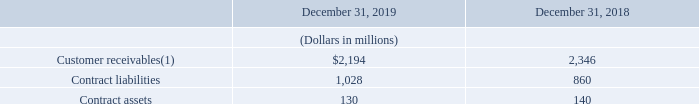Customer Receivables and Contract Balances
The following table provides balances of customer receivables, contract assets and contract liabilities as of December 31, 2019 and December 31, 2018:
(1) Gross customer receivables of $2.3 billion and $2.5 billion, net of allowance for doubtful accounts of $94 million and $132 million, at December 31, 2019 and December 31, 2018, respectively.
Contract liabilities are consideration we have received from our customers or billed in advance of providing goods or services promised in the future. We defer recognizing this consideration as revenue until we have satisfied the related performance obligation to the customer. Contract liabilities include recurring services billed one month in advance and installation and maintenance charges that are deferred and recognized over the actual or expected contract term, which typically ranges from one to five years depending on the service. Contract liabilities are included within deferred revenue in our consolidated balance sheet. During the years ended December 31, 2019 and December 31, 2018, we recognized $630 million and $295 million, respectively, of revenue that was included in contract liabilities as of January 1, 2019 and January 1, 2018, respectively.
What was the gross customer receivables at December 31, 2019? $2.3 billion. What do contract liabilities include? Recurring services billed one month in advance and installation and maintenance charges that are deferred and recognized over the actual or expected contract term, which typically ranges from one to five years depending on the service. What are the items analyzed in the table? Customer receivables, contract liabilities, contract assets. What is the change in net of allowance for doubtful accounts in 2019 from 2018?
Answer scale should be: million. $94-$132
Answer: -38. What is the change in contract liabilities in 2019 from 2018?
Answer scale should be: million. $1,028-$860
Answer: 168. What is the average amount of contract assets for 2018 and 2019?
Answer scale should be: million. ($130+$140)/2
Answer: 135. 